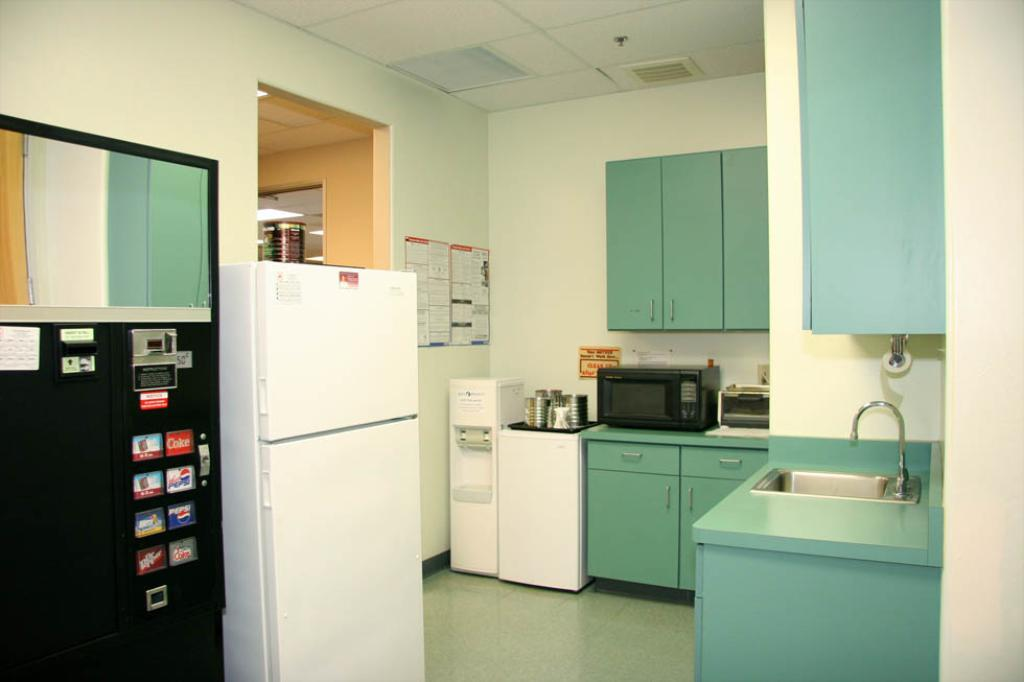<image>
Offer a succinct explanation of the picture presented. A workplace break room has an old looking soda machine that sells Coke. 